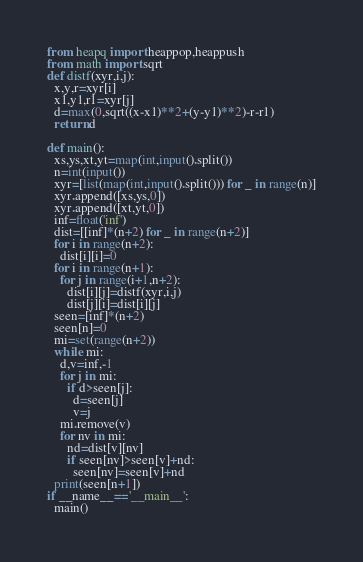Convert code to text. <code><loc_0><loc_0><loc_500><loc_500><_Python_>from heapq import heappop,heappush
from math import sqrt
def distf(xyr,i,j):
  x,y,r=xyr[i]
  x1,y1,r1=xyr[j]
  d=max(0,sqrt((x-x1)**2+(y-y1)**2)-r-r1)
  return d

def main():
  xs,ys,xt,yt=map(int,input().split())
  n=int(input())
  xyr=[list(map(int,input().split())) for _ in range(n)]
  xyr.append([xs,ys,0])
  xyr.append([xt,yt,0])
  inf=float('inf')
  dist=[[inf]*(n+2) for _ in range(n+2)]
  for i in range(n+2):
    dist[i][i]=0
  for i in range(n+1):
    for j in range(i+1,n+2):
      dist[i][j]=distf(xyr,i,j)
      dist[j][i]=dist[i][j]
  seen=[inf]*(n+2)
  seen[n]=0
  mi=set(range(n+2))
  while mi:
    d,v=inf,-1
    for j in mi:
      if d>seen[j]:
        d=seen[j]
        v=j
    mi.remove(v)
    for nv in mi:
      nd=dist[v][nv]
      if seen[nv]>seen[v]+nd:
        seen[nv]=seen[v]+nd
  print(seen[n+1])
if __name__=='__main__':
  main()
</code> 